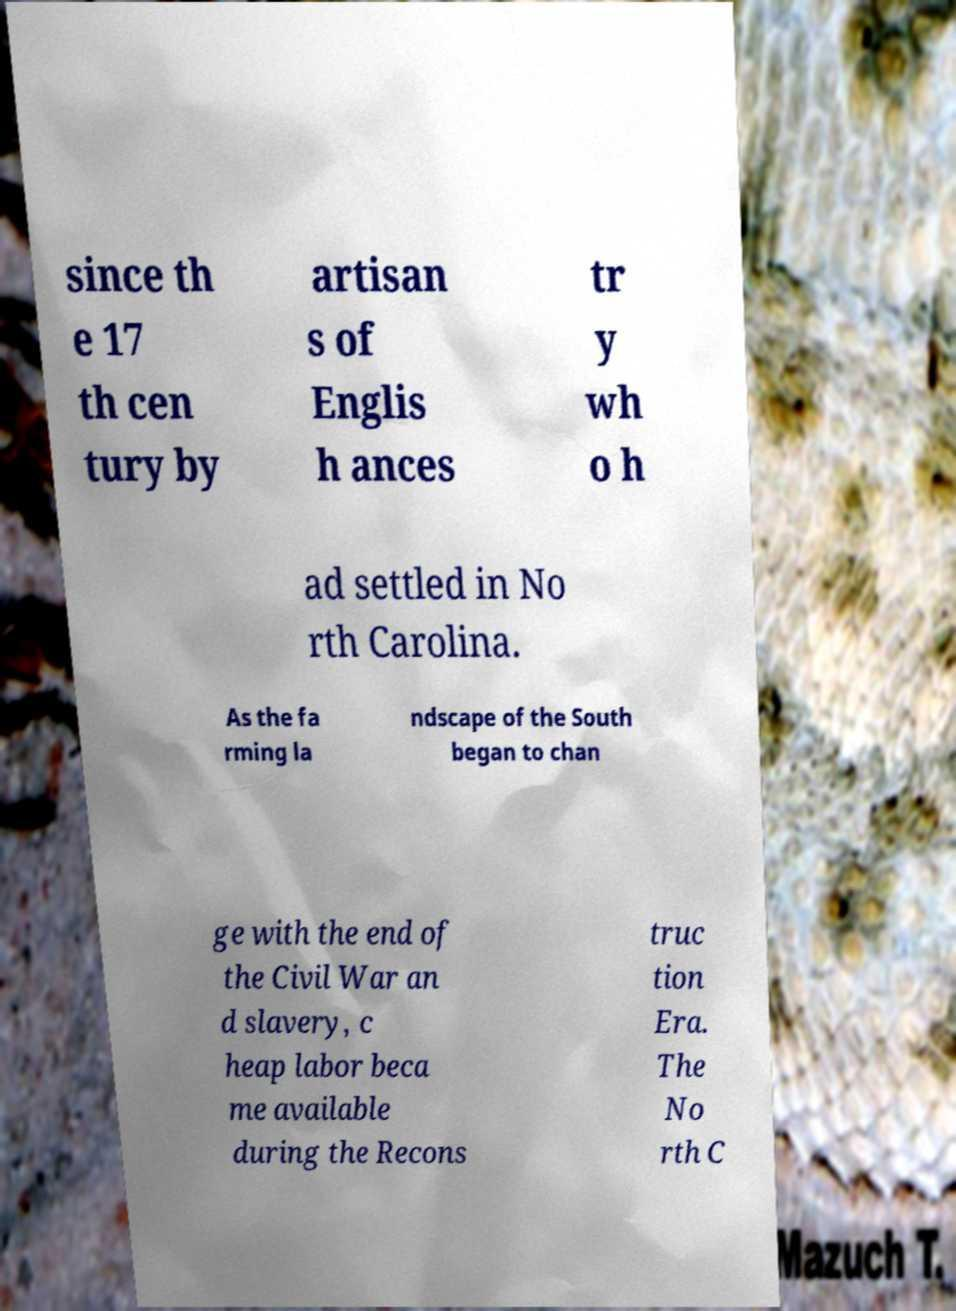For documentation purposes, I need the text within this image transcribed. Could you provide that? since th e 17 th cen tury by artisan s of Englis h ances tr y wh o h ad settled in No rth Carolina. As the fa rming la ndscape of the South began to chan ge with the end of the Civil War an d slavery, c heap labor beca me available during the Recons truc tion Era. The No rth C 